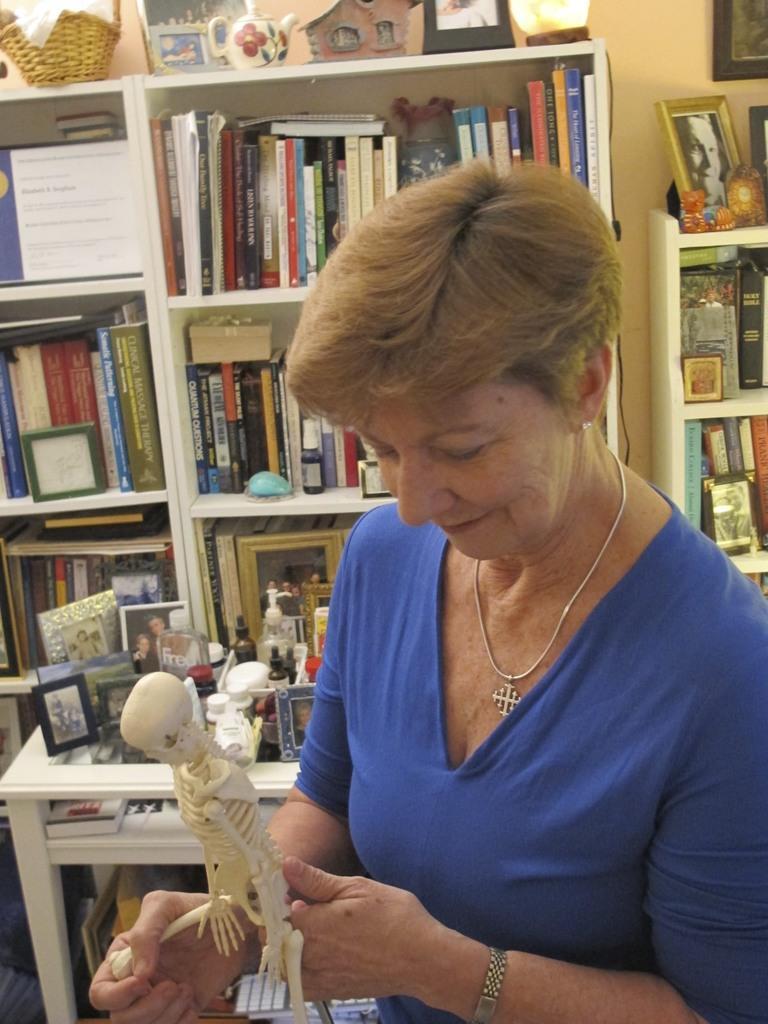Describe this image in one or two sentences. A woman is holding the human skeleton toy and smiling. She wore blue color t-shirt, behind her there are books in the shelves. 